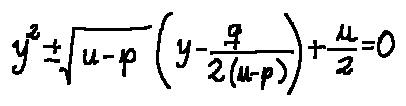Convert formula to latex. <formula><loc_0><loc_0><loc_500><loc_500>y ^ { 2 } \pm \sqrt { u - p } ( y - \frac { q } { 2 ( u - p ) } ) + \frac { u } { 2 } = 0</formula> 